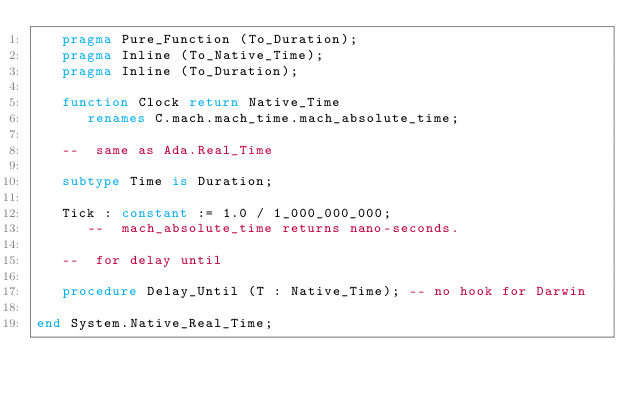<code> <loc_0><loc_0><loc_500><loc_500><_Ada_>   pragma Pure_Function (To_Duration);
   pragma Inline (To_Native_Time);
   pragma Inline (To_Duration);

   function Clock return Native_Time
      renames C.mach.mach_time.mach_absolute_time;

   --  same as Ada.Real_Time

   subtype Time is Duration;

   Tick : constant := 1.0 / 1_000_000_000;
      --  mach_absolute_time returns nano-seconds.

   --  for delay until

   procedure Delay_Until (T : Native_Time); -- no hook for Darwin

end System.Native_Real_Time;
</code> 